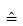<formula> <loc_0><loc_0><loc_500><loc_500>\hat { = }</formula> 